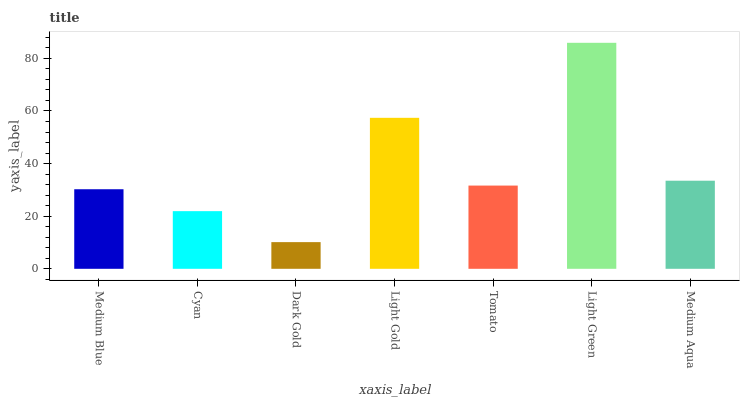Is Dark Gold the minimum?
Answer yes or no. Yes. Is Light Green the maximum?
Answer yes or no. Yes. Is Cyan the minimum?
Answer yes or no. No. Is Cyan the maximum?
Answer yes or no. No. Is Medium Blue greater than Cyan?
Answer yes or no. Yes. Is Cyan less than Medium Blue?
Answer yes or no. Yes. Is Cyan greater than Medium Blue?
Answer yes or no. No. Is Medium Blue less than Cyan?
Answer yes or no. No. Is Tomato the high median?
Answer yes or no. Yes. Is Tomato the low median?
Answer yes or no. Yes. Is Medium Blue the high median?
Answer yes or no. No. Is Light Green the low median?
Answer yes or no. No. 